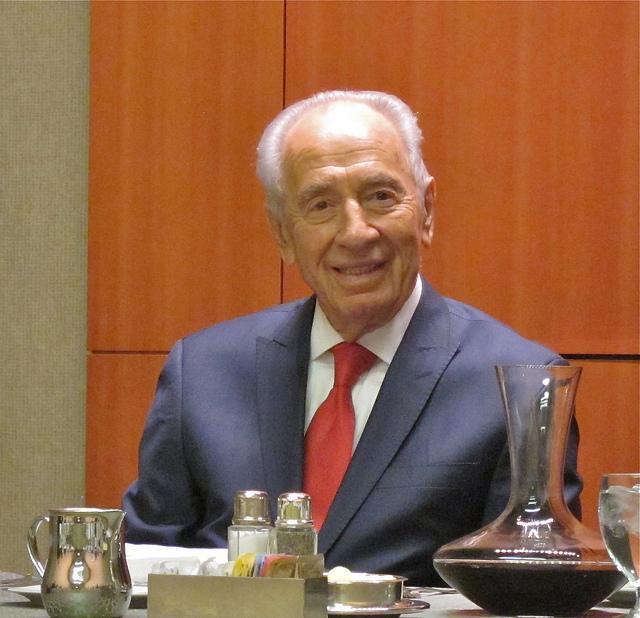Is the given caption "The person is at the left side of the dining table." fitting for the image?
Answer yes or no. No. 